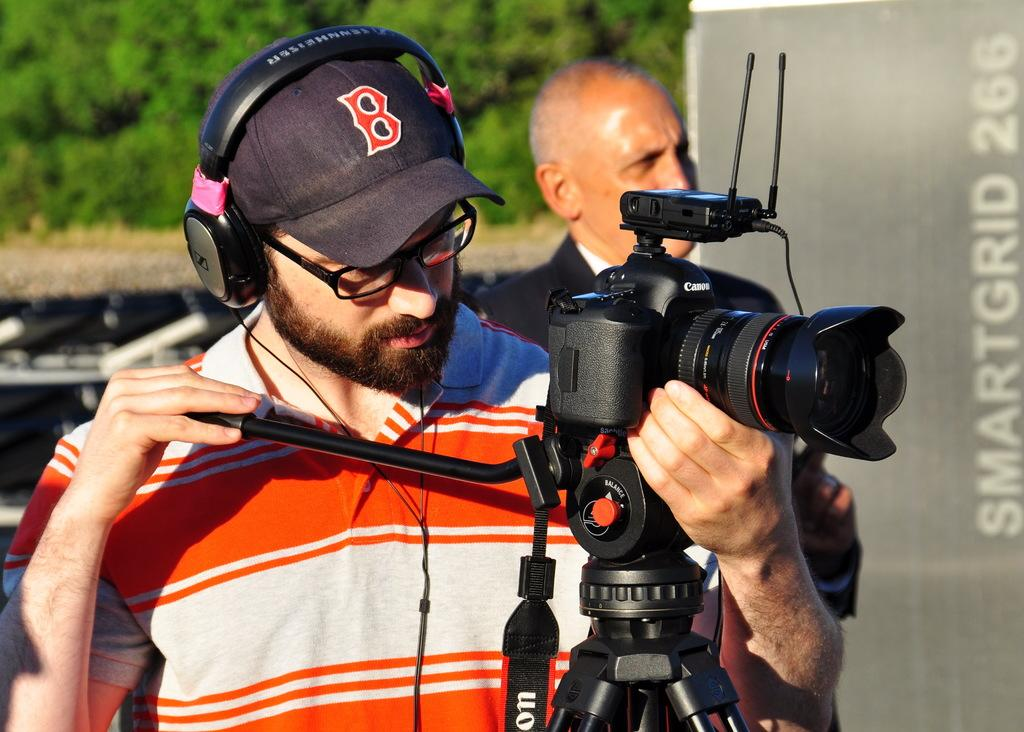What is the man in the image holding? The man is holding a camera. What else can be seen on the man in the image? The man is wearing a headphone. What can be seen in the background of the image? There are trees in the background of the image. What type of quince is the governor using to assert authority in the image? There is no quince, governor, or authority mentioned or depicted in the image. 